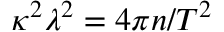<formula> <loc_0><loc_0><loc_500><loc_500>\kappa ^ { 2 } \lambda ^ { 2 } = 4 \pi n / T ^ { 2 }</formula> 